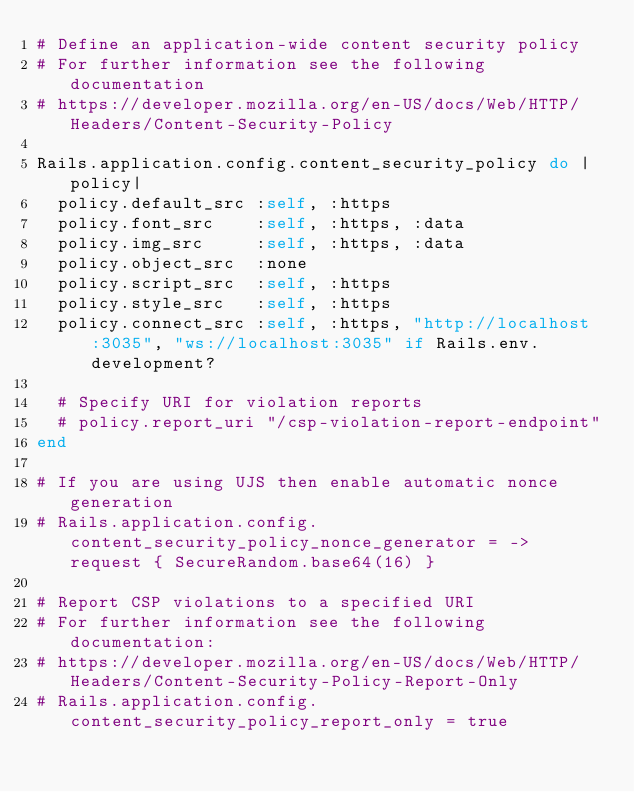<code> <loc_0><loc_0><loc_500><loc_500><_Ruby_># Define an application-wide content security policy
# For further information see the following documentation
# https://developer.mozilla.org/en-US/docs/Web/HTTP/Headers/Content-Security-Policy

Rails.application.config.content_security_policy do |policy|
  policy.default_src :self, :https
  policy.font_src    :self, :https, :data
  policy.img_src     :self, :https, :data
  policy.object_src  :none
  policy.script_src  :self, :https
  policy.style_src   :self, :https
  policy.connect_src :self, :https, "http://localhost:3035", "ws://localhost:3035" if Rails.env.development?

  # Specify URI for violation reports
  # policy.report_uri "/csp-violation-report-endpoint"
end

# If you are using UJS then enable automatic nonce generation
# Rails.application.config.content_security_policy_nonce_generator = -> request { SecureRandom.base64(16) }

# Report CSP violations to a specified URI
# For further information see the following documentation:
# https://developer.mozilla.org/en-US/docs/Web/HTTP/Headers/Content-Security-Policy-Report-Only
# Rails.application.config.content_security_policy_report_only = true
</code> 